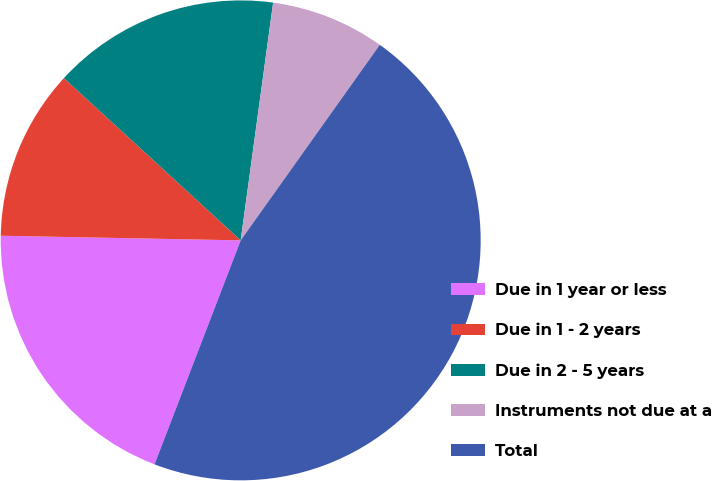Convert chart. <chart><loc_0><loc_0><loc_500><loc_500><pie_chart><fcel>Due in 1 year or less<fcel>Due in 1 - 2 years<fcel>Due in 2 - 5 years<fcel>Instruments not due at a<fcel>Total<nl><fcel>19.46%<fcel>11.51%<fcel>15.34%<fcel>7.68%<fcel>46.0%<nl></chart> 